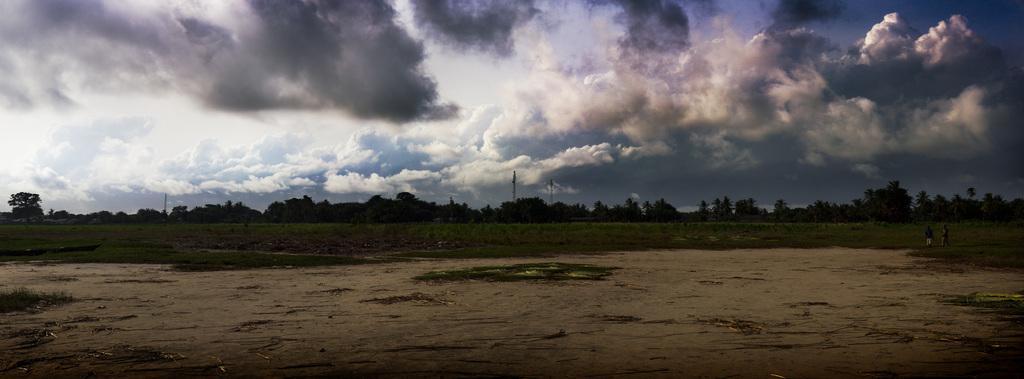In one or two sentences, can you explain what this image depicts? In this image we can see land. Background of the image, grassy land, trees and poles are there. We can see two people are standing on the grassy land. The sky is covered with clouds. 